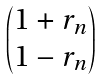<formula> <loc_0><loc_0><loc_500><loc_500>\begin{pmatrix} 1 + r _ { n } \\ 1 - r _ { n } \end{pmatrix}</formula> 